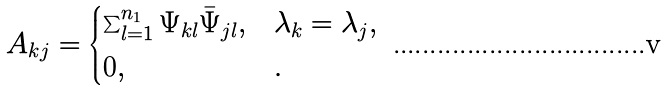Convert formula to latex. <formula><loc_0><loc_0><loc_500><loc_500>A _ { k j } = \begin{cases} \sum _ { l = 1 } ^ { n _ { 1 } } \Psi _ { k l } \bar { \Psi } _ { j l } , & \lambda _ { k } = \lambda _ { j } , \\ 0 , & . \end{cases}</formula> 